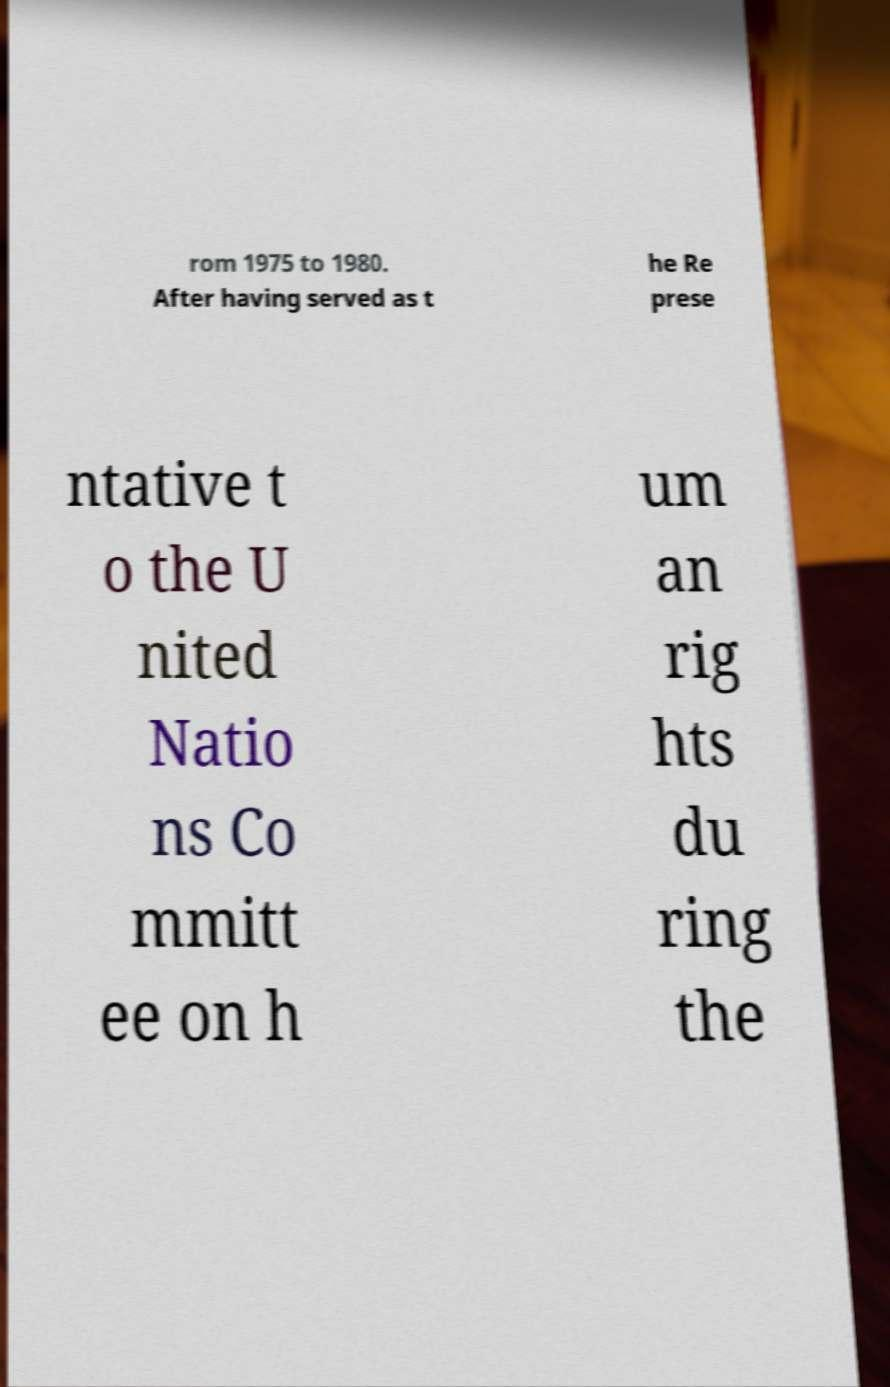Could you extract and type out the text from this image? rom 1975 to 1980. After having served as t he Re prese ntative t o the U nited Natio ns Co mmitt ee on h um an rig hts du ring the 